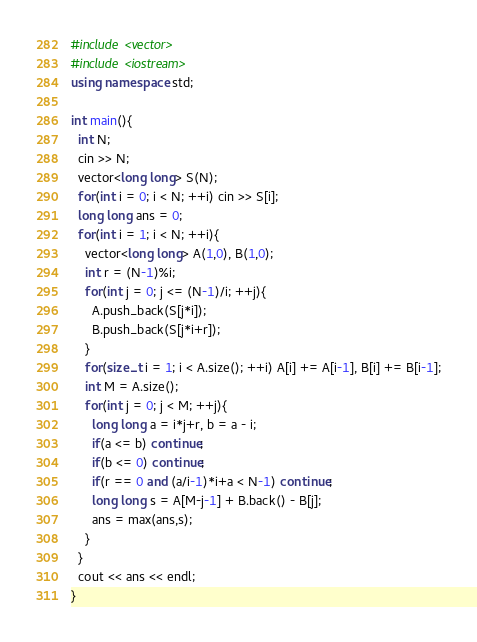Convert code to text. <code><loc_0><loc_0><loc_500><loc_500><_C++_>#include <vector>
#include <iostream>
using namespace std;

int main(){
  int N;
  cin >> N;
  vector<long long> S(N);
  for(int i = 0; i < N; ++i) cin >> S[i];
  long long ans = 0;
  for(int i = 1; i < N; ++i){
    vector<long long> A(1,0), B(1,0);
    int r = (N-1)%i;
    for(int j = 0; j <= (N-1)/i; ++j){
      A.push_back(S[j*i]);
      B.push_back(S[j*i+r]);
    }
    for(size_t i = 1; i < A.size(); ++i) A[i] += A[i-1], B[i] += B[i-1];
    int M = A.size();
    for(int j = 0; j < M; ++j){
      long long a = i*j+r, b = a - i;
      if(a <= b) continue;
      if(b <= 0) continue;
      if(r == 0 and (a/i-1)*i+a < N-1) continue;
      long long s = A[M-j-1] + B.back() - B[j];
      ans = max(ans,s);
    }
  }
  cout << ans << endl;
}
</code> 